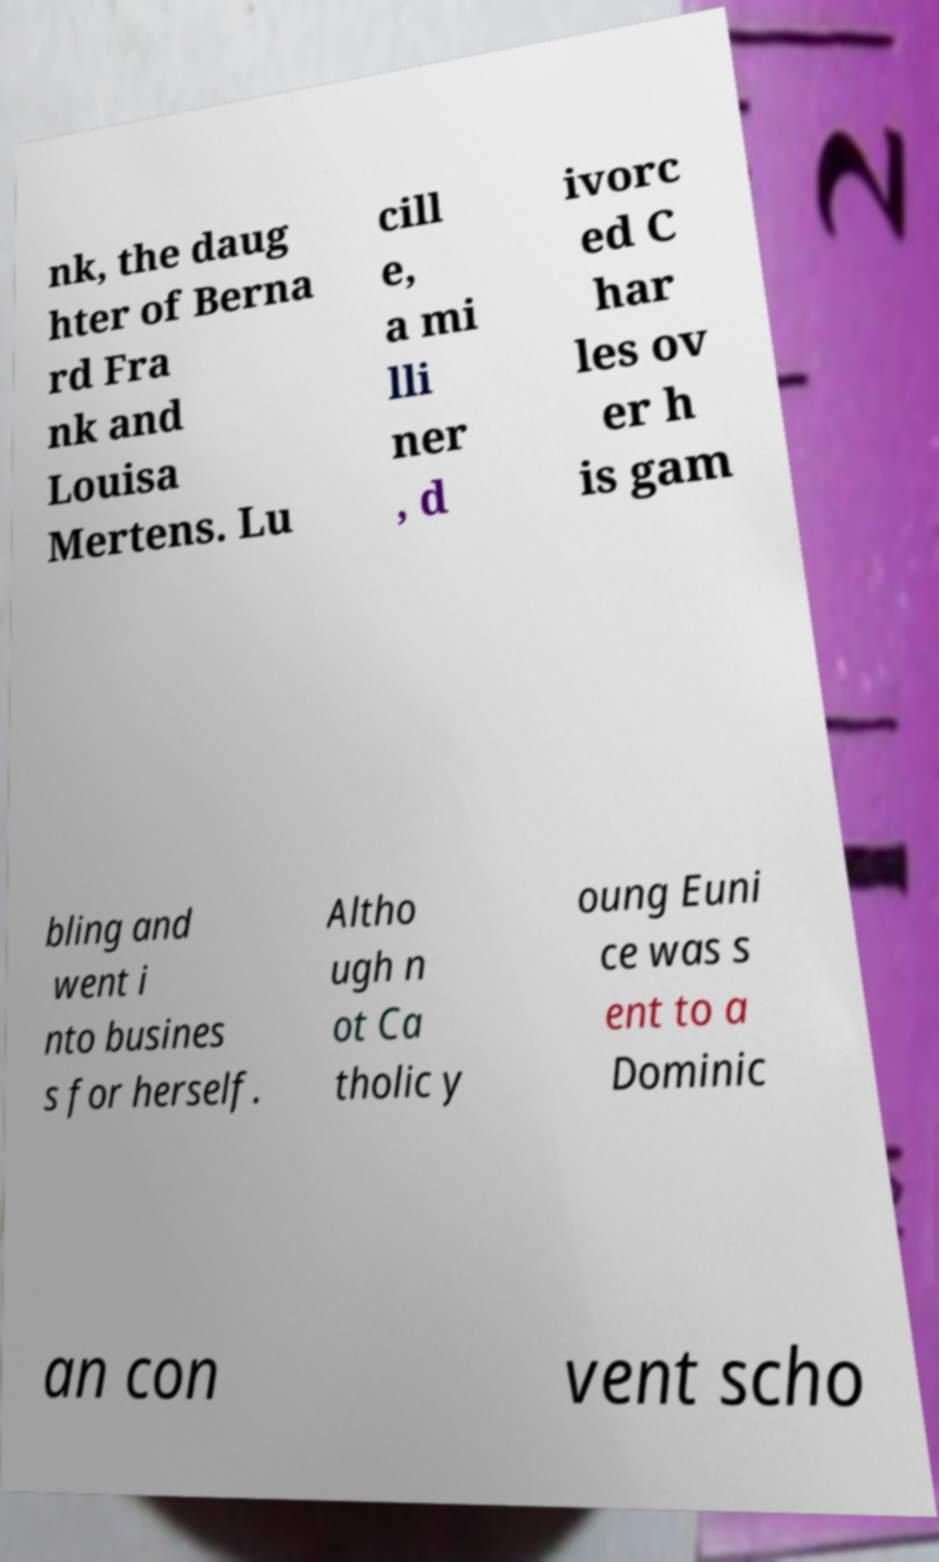Can you accurately transcribe the text from the provided image for me? nk, the daug hter of Berna rd Fra nk and Louisa Mertens. Lu cill e, a mi lli ner , d ivorc ed C har les ov er h is gam bling and went i nto busines s for herself. Altho ugh n ot Ca tholic y oung Euni ce was s ent to a Dominic an con vent scho 